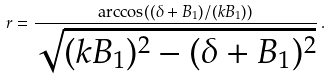<formula> <loc_0><loc_0><loc_500><loc_500>r = \frac { \arccos ( ( \delta + B _ { 1 } ) / ( k B _ { 1 } ) ) } { \sqrt { ( k B _ { 1 } ) ^ { 2 } - ( \delta + B _ { 1 } ) ^ { 2 } } } \, .</formula> 